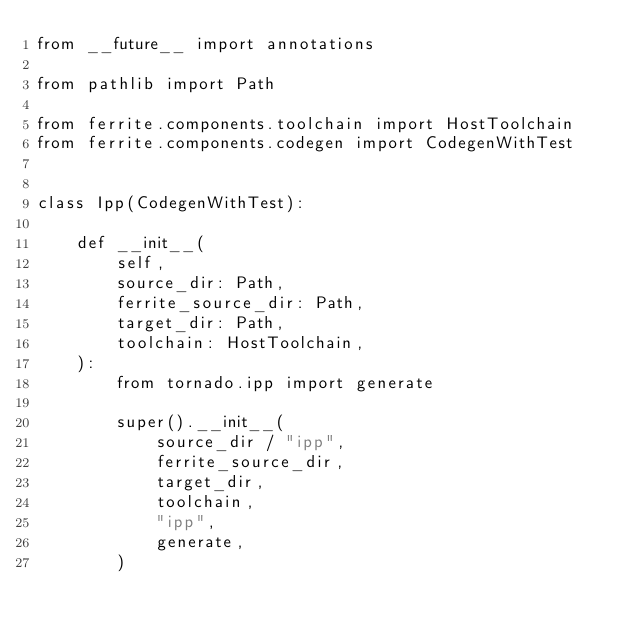Convert code to text. <code><loc_0><loc_0><loc_500><loc_500><_Python_>from __future__ import annotations

from pathlib import Path

from ferrite.components.toolchain import HostToolchain
from ferrite.components.codegen import CodegenWithTest


class Ipp(CodegenWithTest):

    def __init__(
        self,
        source_dir: Path,
        ferrite_source_dir: Path,
        target_dir: Path,
        toolchain: HostToolchain,
    ):
        from tornado.ipp import generate

        super().__init__(
            source_dir / "ipp",
            ferrite_source_dir,
            target_dir,
            toolchain,
            "ipp",
            generate,
        )
</code> 